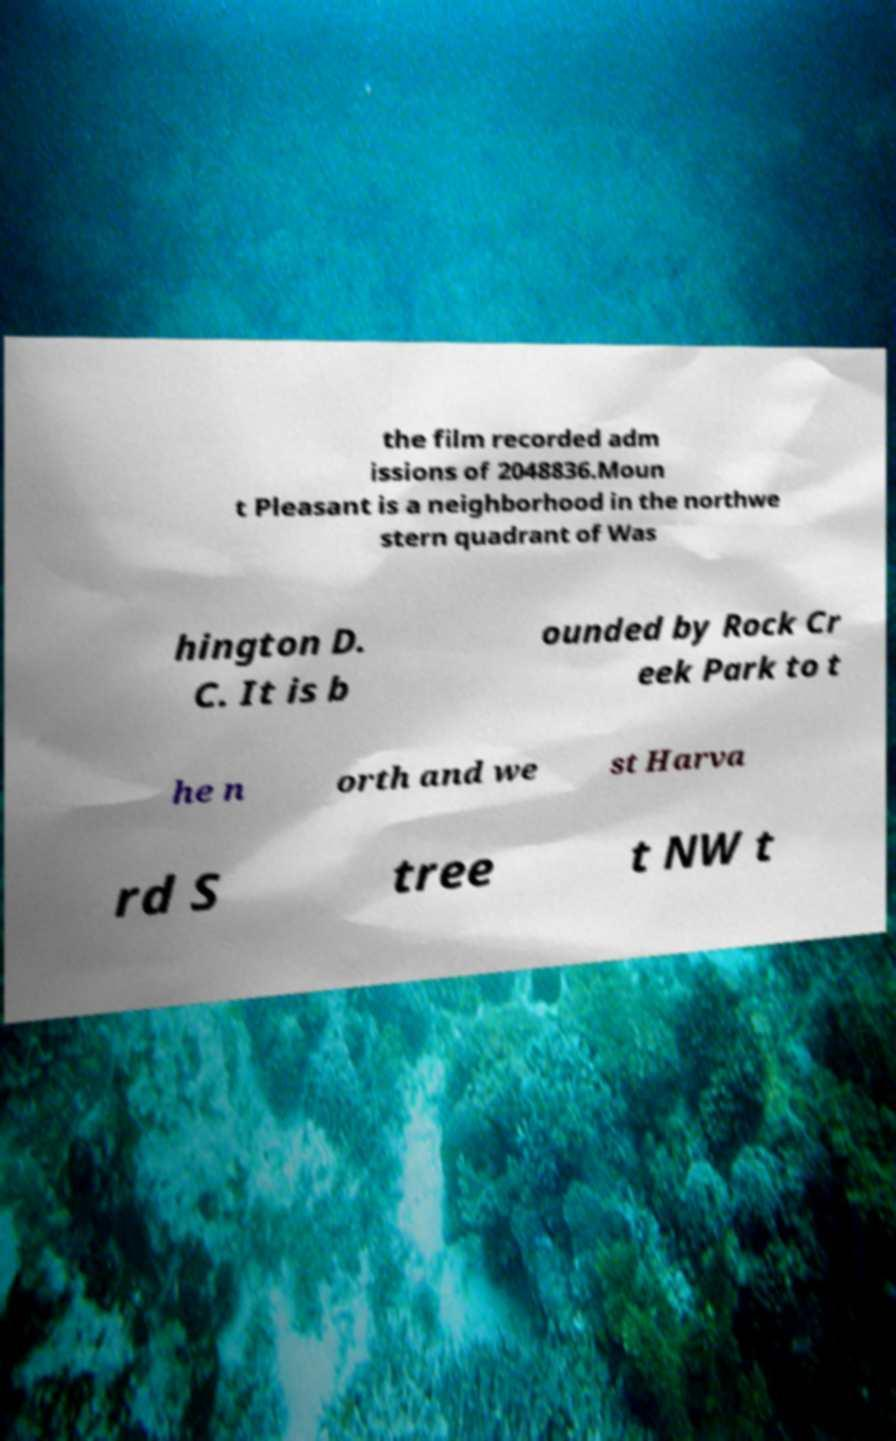Can you read and provide the text displayed in the image?This photo seems to have some interesting text. Can you extract and type it out for me? the film recorded adm issions of 2048836.Moun t Pleasant is a neighborhood in the northwe stern quadrant of Was hington D. C. It is b ounded by Rock Cr eek Park to t he n orth and we st Harva rd S tree t NW t 